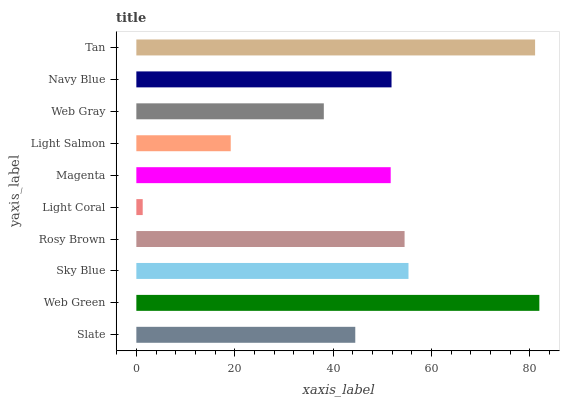Is Light Coral the minimum?
Answer yes or no. Yes. Is Web Green the maximum?
Answer yes or no. Yes. Is Sky Blue the minimum?
Answer yes or no. No. Is Sky Blue the maximum?
Answer yes or no. No. Is Web Green greater than Sky Blue?
Answer yes or no. Yes. Is Sky Blue less than Web Green?
Answer yes or no. Yes. Is Sky Blue greater than Web Green?
Answer yes or no. No. Is Web Green less than Sky Blue?
Answer yes or no. No. Is Navy Blue the high median?
Answer yes or no. Yes. Is Magenta the low median?
Answer yes or no. Yes. Is Magenta the high median?
Answer yes or no. No. Is Light Coral the low median?
Answer yes or no. No. 